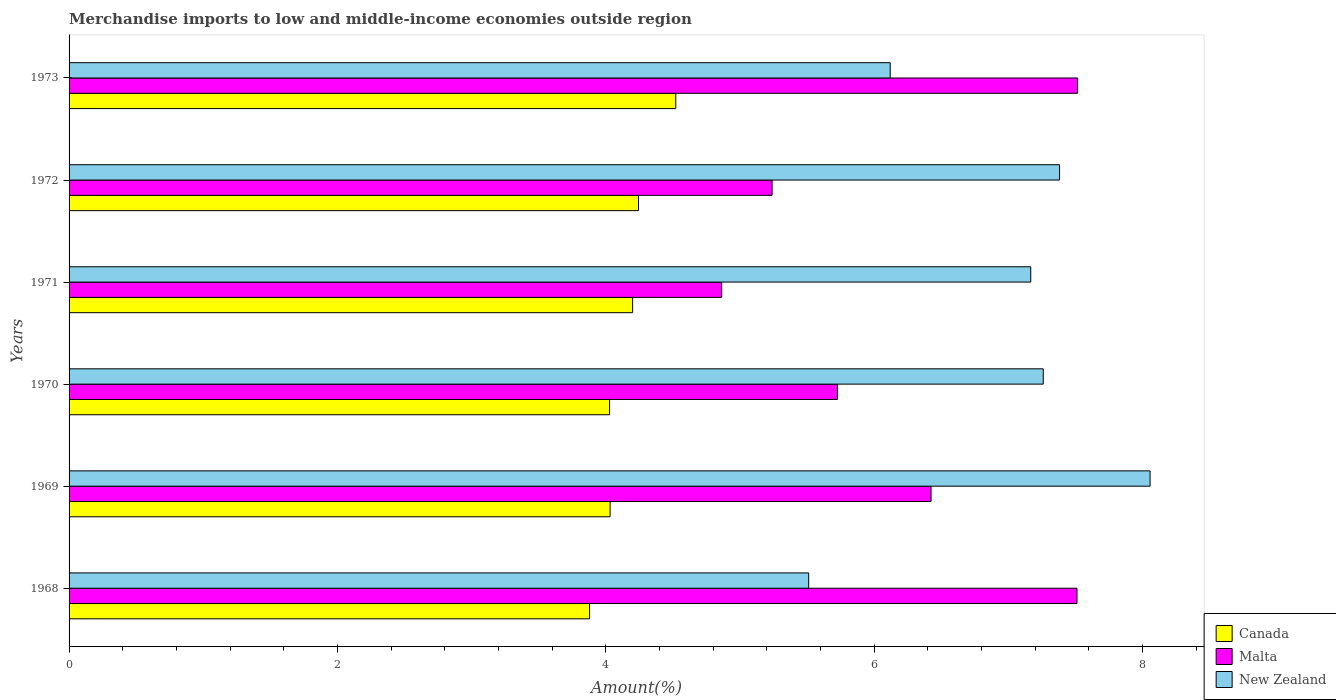Are the number of bars per tick equal to the number of legend labels?
Offer a very short reply. Yes. How many bars are there on the 1st tick from the top?
Provide a succinct answer. 3. How many bars are there on the 4th tick from the bottom?
Offer a very short reply. 3. What is the label of the 1st group of bars from the top?
Offer a very short reply. 1973. What is the percentage of amount earned from merchandise imports in Canada in 1969?
Offer a very short reply. 4.03. Across all years, what is the maximum percentage of amount earned from merchandise imports in New Zealand?
Give a very brief answer. 8.06. Across all years, what is the minimum percentage of amount earned from merchandise imports in Malta?
Ensure brevity in your answer.  4.86. In which year was the percentage of amount earned from merchandise imports in Canada maximum?
Offer a very short reply. 1973. In which year was the percentage of amount earned from merchandise imports in New Zealand minimum?
Your response must be concise. 1968. What is the total percentage of amount earned from merchandise imports in New Zealand in the graph?
Give a very brief answer. 41.5. What is the difference between the percentage of amount earned from merchandise imports in Canada in 1968 and that in 1971?
Ensure brevity in your answer.  -0.32. What is the difference between the percentage of amount earned from merchandise imports in Malta in 1970 and the percentage of amount earned from merchandise imports in New Zealand in 1968?
Keep it short and to the point. 0.21. What is the average percentage of amount earned from merchandise imports in Malta per year?
Keep it short and to the point. 6.21. In the year 1973, what is the difference between the percentage of amount earned from merchandise imports in Canada and percentage of amount earned from merchandise imports in New Zealand?
Your answer should be compact. -1.6. What is the ratio of the percentage of amount earned from merchandise imports in New Zealand in 1969 to that in 1971?
Give a very brief answer. 1.12. What is the difference between the highest and the second highest percentage of amount earned from merchandise imports in New Zealand?
Your answer should be compact. 0.67. What is the difference between the highest and the lowest percentage of amount earned from merchandise imports in New Zealand?
Provide a short and direct response. 2.54. What does the 2nd bar from the top in 1971 represents?
Your response must be concise. Malta. What does the 3rd bar from the bottom in 1970 represents?
Give a very brief answer. New Zealand. How many bars are there?
Make the answer very short. 18. Are all the bars in the graph horizontal?
Provide a succinct answer. Yes. What is the difference between two consecutive major ticks on the X-axis?
Provide a short and direct response. 2. Does the graph contain any zero values?
Provide a short and direct response. No. Where does the legend appear in the graph?
Keep it short and to the point. Bottom right. What is the title of the graph?
Provide a succinct answer. Merchandise imports to low and middle-income economies outside region. What is the label or title of the X-axis?
Ensure brevity in your answer.  Amount(%). What is the Amount(%) of Canada in 1968?
Your answer should be compact. 3.88. What is the Amount(%) of Malta in 1968?
Give a very brief answer. 7.51. What is the Amount(%) in New Zealand in 1968?
Provide a short and direct response. 5.51. What is the Amount(%) of Canada in 1969?
Keep it short and to the point. 4.03. What is the Amount(%) in Malta in 1969?
Ensure brevity in your answer.  6.42. What is the Amount(%) of New Zealand in 1969?
Provide a short and direct response. 8.06. What is the Amount(%) in Canada in 1970?
Your response must be concise. 4.03. What is the Amount(%) of Malta in 1970?
Offer a terse response. 5.73. What is the Amount(%) in New Zealand in 1970?
Your answer should be very brief. 7.26. What is the Amount(%) in Canada in 1971?
Ensure brevity in your answer.  4.2. What is the Amount(%) of Malta in 1971?
Your response must be concise. 4.86. What is the Amount(%) in New Zealand in 1971?
Ensure brevity in your answer.  7.17. What is the Amount(%) in Canada in 1972?
Give a very brief answer. 4.24. What is the Amount(%) in Malta in 1972?
Keep it short and to the point. 5.24. What is the Amount(%) in New Zealand in 1972?
Make the answer very short. 7.38. What is the Amount(%) in Canada in 1973?
Keep it short and to the point. 4.52. What is the Amount(%) in Malta in 1973?
Give a very brief answer. 7.52. What is the Amount(%) of New Zealand in 1973?
Ensure brevity in your answer.  6.12. Across all years, what is the maximum Amount(%) in Canada?
Provide a short and direct response. 4.52. Across all years, what is the maximum Amount(%) in Malta?
Your answer should be very brief. 7.52. Across all years, what is the maximum Amount(%) in New Zealand?
Your answer should be compact. 8.06. Across all years, what is the minimum Amount(%) in Canada?
Offer a very short reply. 3.88. Across all years, what is the minimum Amount(%) of Malta?
Provide a short and direct response. 4.86. Across all years, what is the minimum Amount(%) of New Zealand?
Ensure brevity in your answer.  5.51. What is the total Amount(%) in Canada in the graph?
Make the answer very short. 24.91. What is the total Amount(%) in Malta in the graph?
Offer a very short reply. 37.28. What is the total Amount(%) of New Zealand in the graph?
Give a very brief answer. 41.5. What is the difference between the Amount(%) of Canada in 1968 and that in 1969?
Give a very brief answer. -0.15. What is the difference between the Amount(%) in Malta in 1968 and that in 1969?
Ensure brevity in your answer.  1.09. What is the difference between the Amount(%) in New Zealand in 1968 and that in 1969?
Your answer should be compact. -2.54. What is the difference between the Amount(%) in Canada in 1968 and that in 1970?
Your answer should be compact. -0.15. What is the difference between the Amount(%) of Malta in 1968 and that in 1970?
Your response must be concise. 1.79. What is the difference between the Amount(%) in New Zealand in 1968 and that in 1970?
Your answer should be compact. -1.75. What is the difference between the Amount(%) of Canada in 1968 and that in 1971?
Ensure brevity in your answer.  -0.32. What is the difference between the Amount(%) of Malta in 1968 and that in 1971?
Give a very brief answer. 2.65. What is the difference between the Amount(%) of New Zealand in 1968 and that in 1971?
Your answer should be very brief. -1.65. What is the difference between the Amount(%) in Canada in 1968 and that in 1972?
Your response must be concise. -0.36. What is the difference between the Amount(%) in Malta in 1968 and that in 1972?
Offer a terse response. 2.27. What is the difference between the Amount(%) in New Zealand in 1968 and that in 1972?
Offer a very short reply. -1.87. What is the difference between the Amount(%) of Canada in 1968 and that in 1973?
Offer a terse response. -0.64. What is the difference between the Amount(%) of Malta in 1968 and that in 1973?
Give a very brief answer. -0. What is the difference between the Amount(%) in New Zealand in 1968 and that in 1973?
Provide a short and direct response. -0.61. What is the difference between the Amount(%) of Canada in 1969 and that in 1970?
Make the answer very short. 0. What is the difference between the Amount(%) in Malta in 1969 and that in 1970?
Keep it short and to the point. 0.7. What is the difference between the Amount(%) of New Zealand in 1969 and that in 1970?
Give a very brief answer. 0.8. What is the difference between the Amount(%) in Canada in 1969 and that in 1971?
Provide a short and direct response. -0.17. What is the difference between the Amount(%) of Malta in 1969 and that in 1971?
Your response must be concise. 1.56. What is the difference between the Amount(%) of New Zealand in 1969 and that in 1971?
Ensure brevity in your answer.  0.89. What is the difference between the Amount(%) in Canada in 1969 and that in 1972?
Keep it short and to the point. -0.21. What is the difference between the Amount(%) of Malta in 1969 and that in 1972?
Your answer should be very brief. 1.18. What is the difference between the Amount(%) in New Zealand in 1969 and that in 1972?
Offer a very short reply. 0.67. What is the difference between the Amount(%) in Canada in 1969 and that in 1973?
Offer a very short reply. -0.49. What is the difference between the Amount(%) of Malta in 1969 and that in 1973?
Your answer should be compact. -1.09. What is the difference between the Amount(%) in New Zealand in 1969 and that in 1973?
Provide a short and direct response. 1.94. What is the difference between the Amount(%) of Canada in 1970 and that in 1971?
Give a very brief answer. -0.17. What is the difference between the Amount(%) of Malta in 1970 and that in 1971?
Ensure brevity in your answer.  0.86. What is the difference between the Amount(%) of New Zealand in 1970 and that in 1971?
Your answer should be compact. 0.09. What is the difference between the Amount(%) in Canada in 1970 and that in 1972?
Make the answer very short. -0.22. What is the difference between the Amount(%) in Malta in 1970 and that in 1972?
Provide a short and direct response. 0.49. What is the difference between the Amount(%) of New Zealand in 1970 and that in 1972?
Your answer should be compact. -0.12. What is the difference between the Amount(%) in Canada in 1970 and that in 1973?
Offer a very short reply. -0.49. What is the difference between the Amount(%) of Malta in 1970 and that in 1973?
Ensure brevity in your answer.  -1.79. What is the difference between the Amount(%) in New Zealand in 1970 and that in 1973?
Provide a short and direct response. 1.14. What is the difference between the Amount(%) of Canada in 1971 and that in 1972?
Provide a short and direct response. -0.04. What is the difference between the Amount(%) of Malta in 1971 and that in 1972?
Provide a succinct answer. -0.38. What is the difference between the Amount(%) in New Zealand in 1971 and that in 1972?
Make the answer very short. -0.21. What is the difference between the Amount(%) in Canada in 1971 and that in 1973?
Your answer should be very brief. -0.32. What is the difference between the Amount(%) of Malta in 1971 and that in 1973?
Ensure brevity in your answer.  -2.65. What is the difference between the Amount(%) of New Zealand in 1971 and that in 1973?
Ensure brevity in your answer.  1.05. What is the difference between the Amount(%) of Canada in 1972 and that in 1973?
Your response must be concise. -0.28. What is the difference between the Amount(%) in Malta in 1972 and that in 1973?
Provide a short and direct response. -2.28. What is the difference between the Amount(%) in New Zealand in 1972 and that in 1973?
Offer a terse response. 1.26. What is the difference between the Amount(%) of Canada in 1968 and the Amount(%) of Malta in 1969?
Your answer should be compact. -2.54. What is the difference between the Amount(%) of Canada in 1968 and the Amount(%) of New Zealand in 1969?
Your response must be concise. -4.18. What is the difference between the Amount(%) of Malta in 1968 and the Amount(%) of New Zealand in 1969?
Provide a short and direct response. -0.54. What is the difference between the Amount(%) in Canada in 1968 and the Amount(%) in Malta in 1970?
Provide a short and direct response. -1.85. What is the difference between the Amount(%) in Canada in 1968 and the Amount(%) in New Zealand in 1970?
Ensure brevity in your answer.  -3.38. What is the difference between the Amount(%) of Malta in 1968 and the Amount(%) of New Zealand in 1970?
Provide a short and direct response. 0.25. What is the difference between the Amount(%) in Canada in 1968 and the Amount(%) in Malta in 1971?
Offer a very short reply. -0.98. What is the difference between the Amount(%) of Canada in 1968 and the Amount(%) of New Zealand in 1971?
Provide a short and direct response. -3.29. What is the difference between the Amount(%) in Malta in 1968 and the Amount(%) in New Zealand in 1971?
Give a very brief answer. 0.34. What is the difference between the Amount(%) in Canada in 1968 and the Amount(%) in Malta in 1972?
Make the answer very short. -1.36. What is the difference between the Amount(%) of Canada in 1968 and the Amount(%) of New Zealand in 1972?
Make the answer very short. -3.5. What is the difference between the Amount(%) of Malta in 1968 and the Amount(%) of New Zealand in 1972?
Your answer should be very brief. 0.13. What is the difference between the Amount(%) in Canada in 1968 and the Amount(%) in Malta in 1973?
Your response must be concise. -3.64. What is the difference between the Amount(%) in Canada in 1968 and the Amount(%) in New Zealand in 1973?
Give a very brief answer. -2.24. What is the difference between the Amount(%) in Malta in 1968 and the Amount(%) in New Zealand in 1973?
Your answer should be very brief. 1.39. What is the difference between the Amount(%) of Canada in 1969 and the Amount(%) of Malta in 1970?
Offer a terse response. -1.69. What is the difference between the Amount(%) in Canada in 1969 and the Amount(%) in New Zealand in 1970?
Make the answer very short. -3.23. What is the difference between the Amount(%) in Malta in 1969 and the Amount(%) in New Zealand in 1970?
Ensure brevity in your answer.  -0.84. What is the difference between the Amount(%) of Canada in 1969 and the Amount(%) of Malta in 1971?
Offer a terse response. -0.83. What is the difference between the Amount(%) of Canada in 1969 and the Amount(%) of New Zealand in 1971?
Offer a terse response. -3.13. What is the difference between the Amount(%) in Malta in 1969 and the Amount(%) in New Zealand in 1971?
Ensure brevity in your answer.  -0.74. What is the difference between the Amount(%) in Canada in 1969 and the Amount(%) in Malta in 1972?
Your answer should be compact. -1.21. What is the difference between the Amount(%) of Canada in 1969 and the Amount(%) of New Zealand in 1972?
Provide a short and direct response. -3.35. What is the difference between the Amount(%) in Malta in 1969 and the Amount(%) in New Zealand in 1972?
Keep it short and to the point. -0.96. What is the difference between the Amount(%) in Canada in 1969 and the Amount(%) in Malta in 1973?
Your answer should be very brief. -3.48. What is the difference between the Amount(%) of Canada in 1969 and the Amount(%) of New Zealand in 1973?
Provide a succinct answer. -2.09. What is the difference between the Amount(%) of Malta in 1969 and the Amount(%) of New Zealand in 1973?
Provide a succinct answer. 0.3. What is the difference between the Amount(%) in Canada in 1970 and the Amount(%) in Malta in 1971?
Give a very brief answer. -0.84. What is the difference between the Amount(%) of Canada in 1970 and the Amount(%) of New Zealand in 1971?
Give a very brief answer. -3.14. What is the difference between the Amount(%) of Malta in 1970 and the Amount(%) of New Zealand in 1971?
Your answer should be compact. -1.44. What is the difference between the Amount(%) in Canada in 1970 and the Amount(%) in Malta in 1972?
Provide a succinct answer. -1.21. What is the difference between the Amount(%) of Canada in 1970 and the Amount(%) of New Zealand in 1972?
Offer a terse response. -3.35. What is the difference between the Amount(%) of Malta in 1970 and the Amount(%) of New Zealand in 1972?
Keep it short and to the point. -1.66. What is the difference between the Amount(%) of Canada in 1970 and the Amount(%) of Malta in 1973?
Your answer should be compact. -3.49. What is the difference between the Amount(%) in Canada in 1970 and the Amount(%) in New Zealand in 1973?
Offer a very short reply. -2.09. What is the difference between the Amount(%) of Malta in 1970 and the Amount(%) of New Zealand in 1973?
Give a very brief answer. -0.39. What is the difference between the Amount(%) in Canada in 1971 and the Amount(%) in Malta in 1972?
Keep it short and to the point. -1.04. What is the difference between the Amount(%) in Canada in 1971 and the Amount(%) in New Zealand in 1972?
Keep it short and to the point. -3.18. What is the difference between the Amount(%) in Malta in 1971 and the Amount(%) in New Zealand in 1972?
Make the answer very short. -2.52. What is the difference between the Amount(%) in Canada in 1971 and the Amount(%) in Malta in 1973?
Give a very brief answer. -3.32. What is the difference between the Amount(%) in Canada in 1971 and the Amount(%) in New Zealand in 1973?
Keep it short and to the point. -1.92. What is the difference between the Amount(%) in Malta in 1971 and the Amount(%) in New Zealand in 1973?
Your answer should be compact. -1.26. What is the difference between the Amount(%) of Canada in 1972 and the Amount(%) of Malta in 1973?
Offer a very short reply. -3.27. What is the difference between the Amount(%) in Canada in 1972 and the Amount(%) in New Zealand in 1973?
Your answer should be very brief. -1.88. What is the difference between the Amount(%) in Malta in 1972 and the Amount(%) in New Zealand in 1973?
Keep it short and to the point. -0.88. What is the average Amount(%) in Canada per year?
Your response must be concise. 4.15. What is the average Amount(%) in Malta per year?
Keep it short and to the point. 6.21. What is the average Amount(%) in New Zealand per year?
Your answer should be very brief. 6.92. In the year 1968, what is the difference between the Amount(%) in Canada and Amount(%) in Malta?
Offer a terse response. -3.63. In the year 1968, what is the difference between the Amount(%) in Canada and Amount(%) in New Zealand?
Your answer should be compact. -1.63. In the year 1968, what is the difference between the Amount(%) of Malta and Amount(%) of New Zealand?
Your response must be concise. 2. In the year 1969, what is the difference between the Amount(%) of Canada and Amount(%) of Malta?
Provide a succinct answer. -2.39. In the year 1969, what is the difference between the Amount(%) in Canada and Amount(%) in New Zealand?
Make the answer very short. -4.02. In the year 1969, what is the difference between the Amount(%) of Malta and Amount(%) of New Zealand?
Give a very brief answer. -1.63. In the year 1970, what is the difference between the Amount(%) of Canada and Amount(%) of Malta?
Your answer should be compact. -1.7. In the year 1970, what is the difference between the Amount(%) in Canada and Amount(%) in New Zealand?
Your answer should be very brief. -3.23. In the year 1970, what is the difference between the Amount(%) in Malta and Amount(%) in New Zealand?
Your response must be concise. -1.53. In the year 1971, what is the difference between the Amount(%) in Canada and Amount(%) in Malta?
Keep it short and to the point. -0.66. In the year 1971, what is the difference between the Amount(%) in Canada and Amount(%) in New Zealand?
Offer a very short reply. -2.97. In the year 1971, what is the difference between the Amount(%) of Malta and Amount(%) of New Zealand?
Provide a succinct answer. -2.3. In the year 1972, what is the difference between the Amount(%) of Canada and Amount(%) of Malta?
Ensure brevity in your answer.  -1. In the year 1972, what is the difference between the Amount(%) in Canada and Amount(%) in New Zealand?
Ensure brevity in your answer.  -3.14. In the year 1972, what is the difference between the Amount(%) of Malta and Amount(%) of New Zealand?
Your response must be concise. -2.14. In the year 1973, what is the difference between the Amount(%) of Canada and Amount(%) of Malta?
Make the answer very short. -2.99. In the year 1973, what is the difference between the Amount(%) of Canada and Amount(%) of New Zealand?
Offer a terse response. -1.6. In the year 1973, what is the difference between the Amount(%) in Malta and Amount(%) in New Zealand?
Make the answer very short. 1.4. What is the ratio of the Amount(%) in Canada in 1968 to that in 1969?
Provide a short and direct response. 0.96. What is the ratio of the Amount(%) of Malta in 1968 to that in 1969?
Your answer should be compact. 1.17. What is the ratio of the Amount(%) of New Zealand in 1968 to that in 1969?
Your response must be concise. 0.68. What is the ratio of the Amount(%) in Malta in 1968 to that in 1970?
Offer a very short reply. 1.31. What is the ratio of the Amount(%) of New Zealand in 1968 to that in 1970?
Offer a terse response. 0.76. What is the ratio of the Amount(%) in Canada in 1968 to that in 1971?
Your answer should be compact. 0.92. What is the ratio of the Amount(%) in Malta in 1968 to that in 1971?
Keep it short and to the point. 1.54. What is the ratio of the Amount(%) in New Zealand in 1968 to that in 1971?
Provide a short and direct response. 0.77. What is the ratio of the Amount(%) in Canada in 1968 to that in 1972?
Offer a terse response. 0.91. What is the ratio of the Amount(%) of Malta in 1968 to that in 1972?
Offer a terse response. 1.43. What is the ratio of the Amount(%) in New Zealand in 1968 to that in 1972?
Your answer should be compact. 0.75. What is the ratio of the Amount(%) of Canada in 1968 to that in 1973?
Offer a terse response. 0.86. What is the ratio of the Amount(%) in New Zealand in 1968 to that in 1973?
Give a very brief answer. 0.9. What is the ratio of the Amount(%) in Malta in 1969 to that in 1970?
Keep it short and to the point. 1.12. What is the ratio of the Amount(%) in New Zealand in 1969 to that in 1970?
Ensure brevity in your answer.  1.11. What is the ratio of the Amount(%) in Canada in 1969 to that in 1971?
Provide a short and direct response. 0.96. What is the ratio of the Amount(%) in Malta in 1969 to that in 1971?
Provide a short and direct response. 1.32. What is the ratio of the Amount(%) of New Zealand in 1969 to that in 1971?
Give a very brief answer. 1.12. What is the ratio of the Amount(%) of Canada in 1969 to that in 1972?
Make the answer very short. 0.95. What is the ratio of the Amount(%) in Malta in 1969 to that in 1972?
Provide a succinct answer. 1.23. What is the ratio of the Amount(%) of New Zealand in 1969 to that in 1972?
Provide a succinct answer. 1.09. What is the ratio of the Amount(%) in Canada in 1969 to that in 1973?
Your answer should be compact. 0.89. What is the ratio of the Amount(%) of Malta in 1969 to that in 1973?
Provide a short and direct response. 0.85. What is the ratio of the Amount(%) of New Zealand in 1969 to that in 1973?
Your answer should be very brief. 1.32. What is the ratio of the Amount(%) of Canada in 1970 to that in 1971?
Provide a short and direct response. 0.96. What is the ratio of the Amount(%) of Malta in 1970 to that in 1971?
Your answer should be compact. 1.18. What is the ratio of the Amount(%) in New Zealand in 1970 to that in 1971?
Give a very brief answer. 1.01. What is the ratio of the Amount(%) of Canada in 1970 to that in 1972?
Your answer should be very brief. 0.95. What is the ratio of the Amount(%) of Malta in 1970 to that in 1972?
Your answer should be compact. 1.09. What is the ratio of the Amount(%) in New Zealand in 1970 to that in 1972?
Provide a short and direct response. 0.98. What is the ratio of the Amount(%) of Canada in 1970 to that in 1973?
Ensure brevity in your answer.  0.89. What is the ratio of the Amount(%) of Malta in 1970 to that in 1973?
Keep it short and to the point. 0.76. What is the ratio of the Amount(%) of New Zealand in 1970 to that in 1973?
Offer a terse response. 1.19. What is the ratio of the Amount(%) in Malta in 1971 to that in 1972?
Ensure brevity in your answer.  0.93. What is the ratio of the Amount(%) in New Zealand in 1971 to that in 1972?
Offer a very short reply. 0.97. What is the ratio of the Amount(%) in Canada in 1971 to that in 1973?
Keep it short and to the point. 0.93. What is the ratio of the Amount(%) in Malta in 1971 to that in 1973?
Provide a succinct answer. 0.65. What is the ratio of the Amount(%) in New Zealand in 1971 to that in 1973?
Offer a terse response. 1.17. What is the ratio of the Amount(%) in Canada in 1972 to that in 1973?
Make the answer very short. 0.94. What is the ratio of the Amount(%) in Malta in 1972 to that in 1973?
Offer a terse response. 0.7. What is the ratio of the Amount(%) in New Zealand in 1972 to that in 1973?
Provide a succinct answer. 1.21. What is the difference between the highest and the second highest Amount(%) of Canada?
Your response must be concise. 0.28. What is the difference between the highest and the second highest Amount(%) in Malta?
Provide a short and direct response. 0. What is the difference between the highest and the second highest Amount(%) of New Zealand?
Provide a short and direct response. 0.67. What is the difference between the highest and the lowest Amount(%) of Canada?
Your answer should be very brief. 0.64. What is the difference between the highest and the lowest Amount(%) in Malta?
Give a very brief answer. 2.65. What is the difference between the highest and the lowest Amount(%) in New Zealand?
Your answer should be very brief. 2.54. 